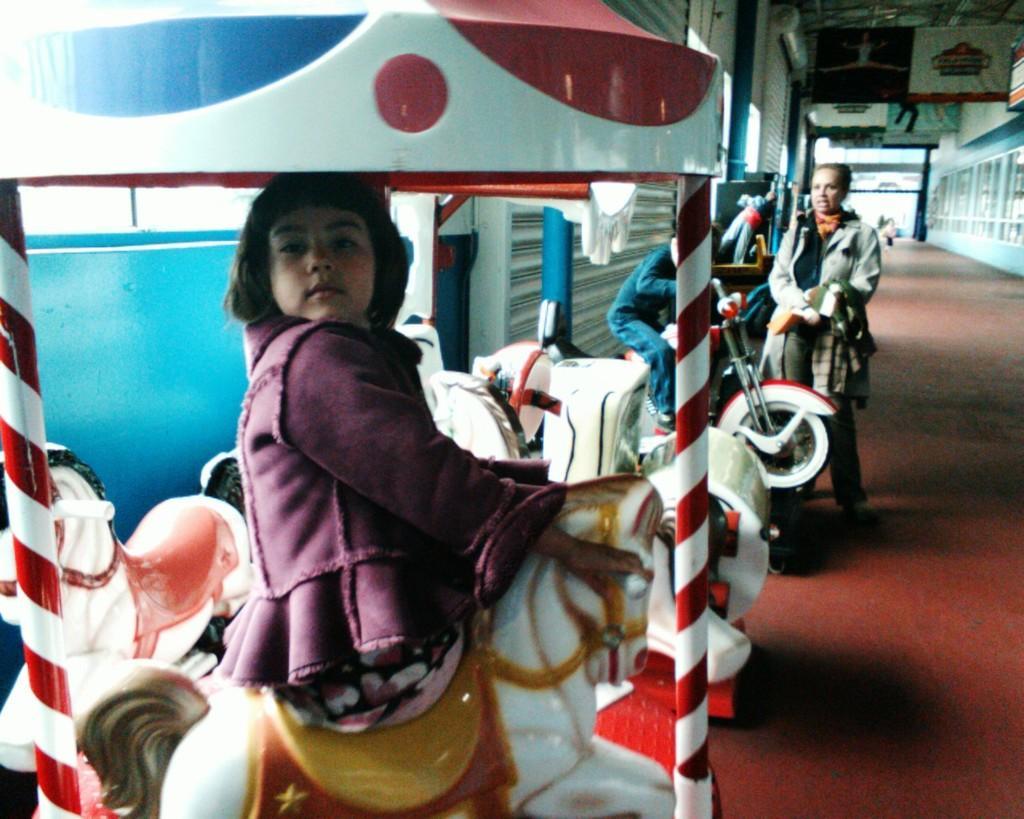Can you describe this image briefly? There is a girl sitting on toy horse,there is a woman standing and holding cloth and there is a kid sitting on bike. We can see wall,banners and floor. 